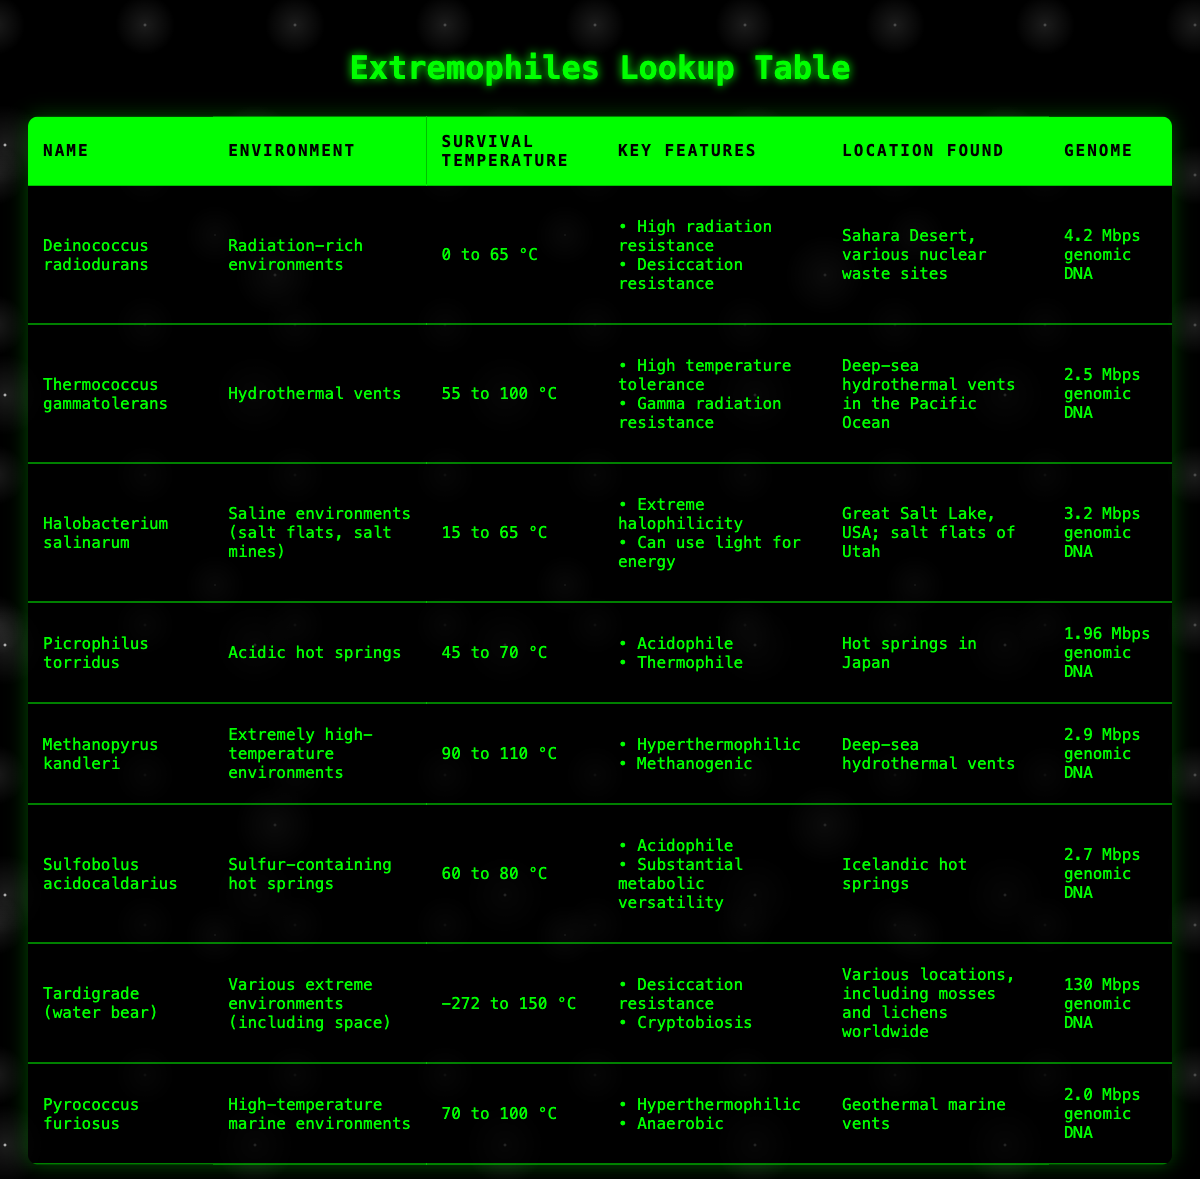What is the survival temperature range for Halobacterium salinarum? The table shows that Halobacterium salinarum has a survival temperature range of 15 to 65 °C, listed in the corresponding column for survival temperature.
Answer: 15 to 65 °C Which organism can survive at the highest temperature, and what is that temperature? From the survival temperature data in the table, Methanopyrus kandleri has the highest temperature range of 90 to 110 °C. Thus, it can survive at 110 °C.
Answer: Methanopyrus kandleri, 110 °C Is Tardigrade (water bear) found in all extreme environments? The table indicates that Tardigrades are found in "various extreme environments (including space)," which supports the idea they can survive in many harsh conditions, suggesting a "yes" answer.
Answer: Yes What are the key features of Pyrococcus furiosus? Referring to the information given in the table for Pyrococcus furiosus, the key features listed are "Hyperthermophilic" and "Anaerobic."
Answer: Hyperthermophilic, Anaerobic What is the average genome size of the extremophiles listed? The genome sizes can be summed as follows: 4.2 + 2.5 + 3.2 + 1.96 + 2.9 + 2.7 + 130 + 2.0 = 149.56 Mbps. Then, dividing this sum by the total number of extremophiles (8) gives an average of 149.56 / 8 = 18.695 Mbps.
Answer: 18.695 Mbps Which extremophile is classified as an acidophile and what environments are they found in? According to the table, both Picrophilus torridus and Sulfobolus acidocaldarius are classified as acidophiles. Picrophilus torridus is found in acidic hot springs while Sulfobolus acidocaldarius is found in sulfur-containing hot springs.
Answer: Picrophilus torridus and Sulfobolus acidocaldarius; acidic hot springs and sulfur-containing hot springs How many extremophiles can survive temperatures below freezing? Evaluating the survival temperature ranges, only Tardigrade (water bear) shows a range that includes temperatures as low as −272 °C, meaning it is the only extremophile included that can survive below freezing.
Answer: 1 Is it true that all extremophiles in the table can survive above 0 °C? By checking the survival ranges, it is clear that Deinococcus radiodurans can survive starting from 0 °C, while the other organisms listed either begin their survival ranges above 0 °C or can tolerate significantly higher temperatures. Thus, the statement is true.
Answer: Yes 